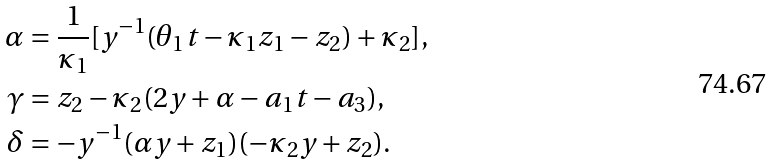<formula> <loc_0><loc_0><loc_500><loc_500>\alpha & = \frac { 1 } { \kappa _ { 1 } } [ y ^ { - 1 } ( \theta _ { 1 } t - \kappa _ { 1 } z _ { 1 } - z _ { 2 } ) + \kappa _ { 2 } ] , \\ \gamma & = z _ { 2 } - \kappa _ { 2 } ( 2 y + \alpha - a _ { 1 } t - a _ { 3 } ) , \\ \delta & = - y ^ { - 1 } ( \alpha y + z _ { 1 } ) ( - \kappa _ { 2 } y + z _ { 2 } ) .</formula> 